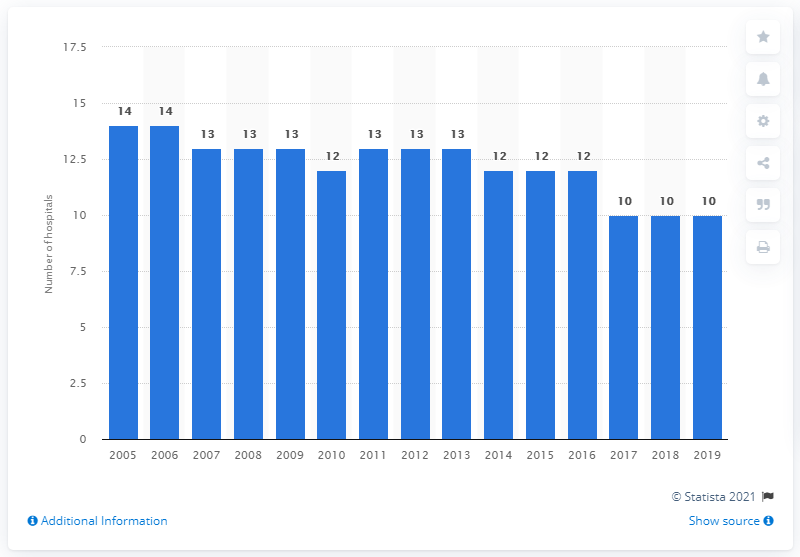Specify some key components in this picture. Since 2005, the number of hospitals in Luxembourg has decreased. 